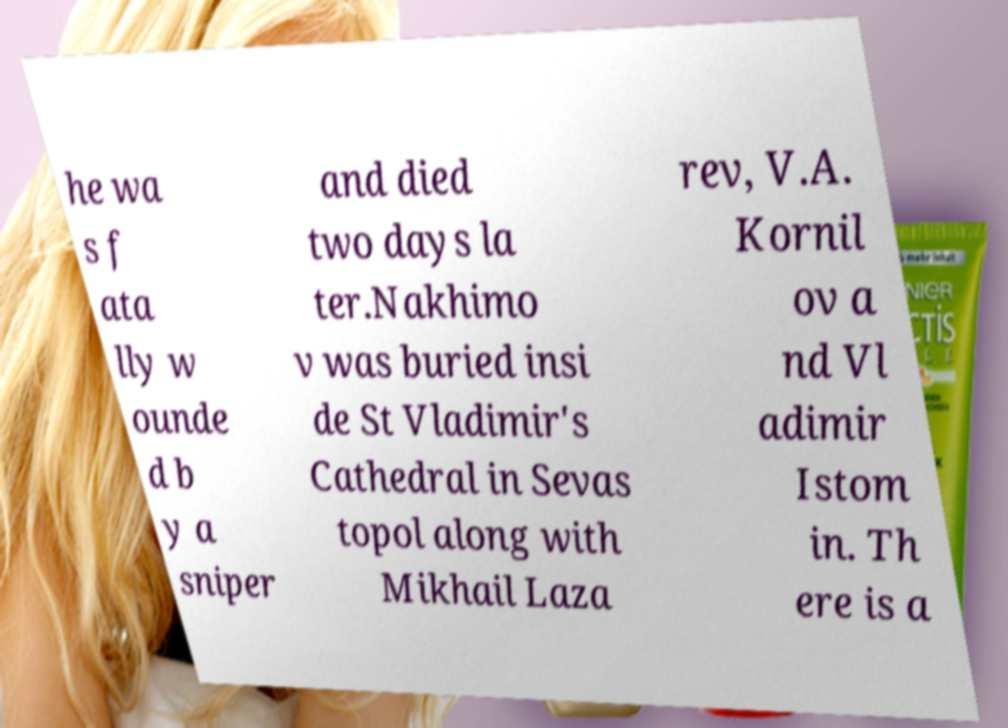Could you extract and type out the text from this image? he wa s f ata lly w ounde d b y a sniper and died two days la ter.Nakhimo v was buried insi de St Vladimir's Cathedral in Sevas topol along with Mikhail Laza rev, V.A. Kornil ov a nd Vl adimir Istom in. Th ere is a 